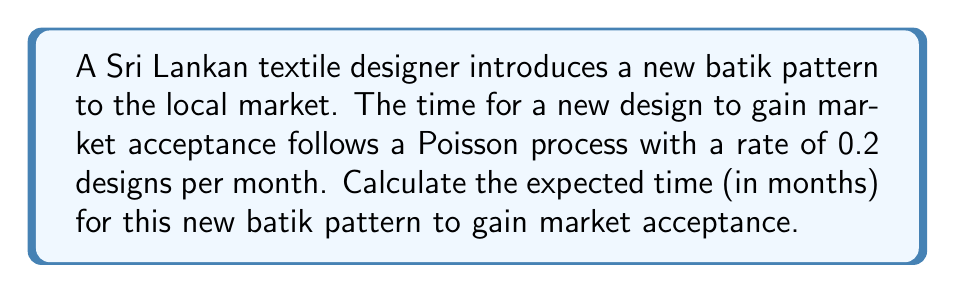Show me your answer to this math problem. To solve this problem, we need to understand the properties of a Poisson process:

1. In a Poisson process, the time between events (in this case, market acceptance) follows an exponential distribution.

2. The rate parameter λ of the Poisson process is given as 0.2 designs per month.

3. For an exponential distribution, the expected value (mean) is the reciprocal of the rate parameter.

Let T be the random variable representing the time for the design to gain market acceptance.

The expected value of T is:

$$ E[T] = \frac{1}{\lambda} $$

Substituting the given rate:

$$ E[T] = \frac{1}{0.2} = 5 $$

Therefore, the expected time for the new batik pattern to gain market acceptance is 5 months.
Answer: 5 months 